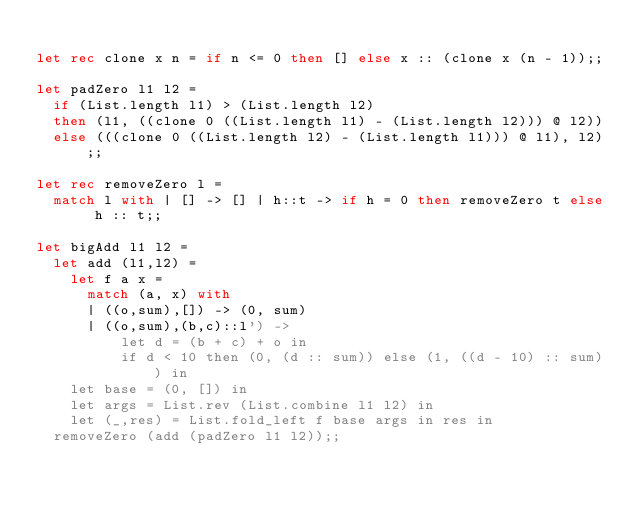Convert code to text. <code><loc_0><loc_0><loc_500><loc_500><_OCaml_>
let rec clone x n = if n <= 0 then [] else x :: (clone x (n - 1));;

let padZero l1 l2 =
  if (List.length l1) > (List.length l2)
  then (l1, ((clone 0 ((List.length l1) - (List.length l2))) @ l2))
  else (((clone 0 ((List.length l2) - (List.length l1))) @ l1), l2);;

let rec removeZero l =
  match l with | [] -> [] | h::t -> if h = 0 then removeZero t else h :: t;;

let bigAdd l1 l2 =
  let add (l1,l2) =
    let f a x =
      match (a, x) with
      | ((o,sum),[]) -> (0, sum)
      | ((o,sum),(b,c)::l') ->
          let d = (b + c) + o in
          if d < 10 then (0, (d :: sum)) else (1, ((d - 10) :: sum)) in
    let base = (0, []) in
    let args = List.rev (List.combine l1 l2) in
    let (_,res) = List.fold_left f base args in res in
  removeZero (add (padZero l1 l2));;
</code> 